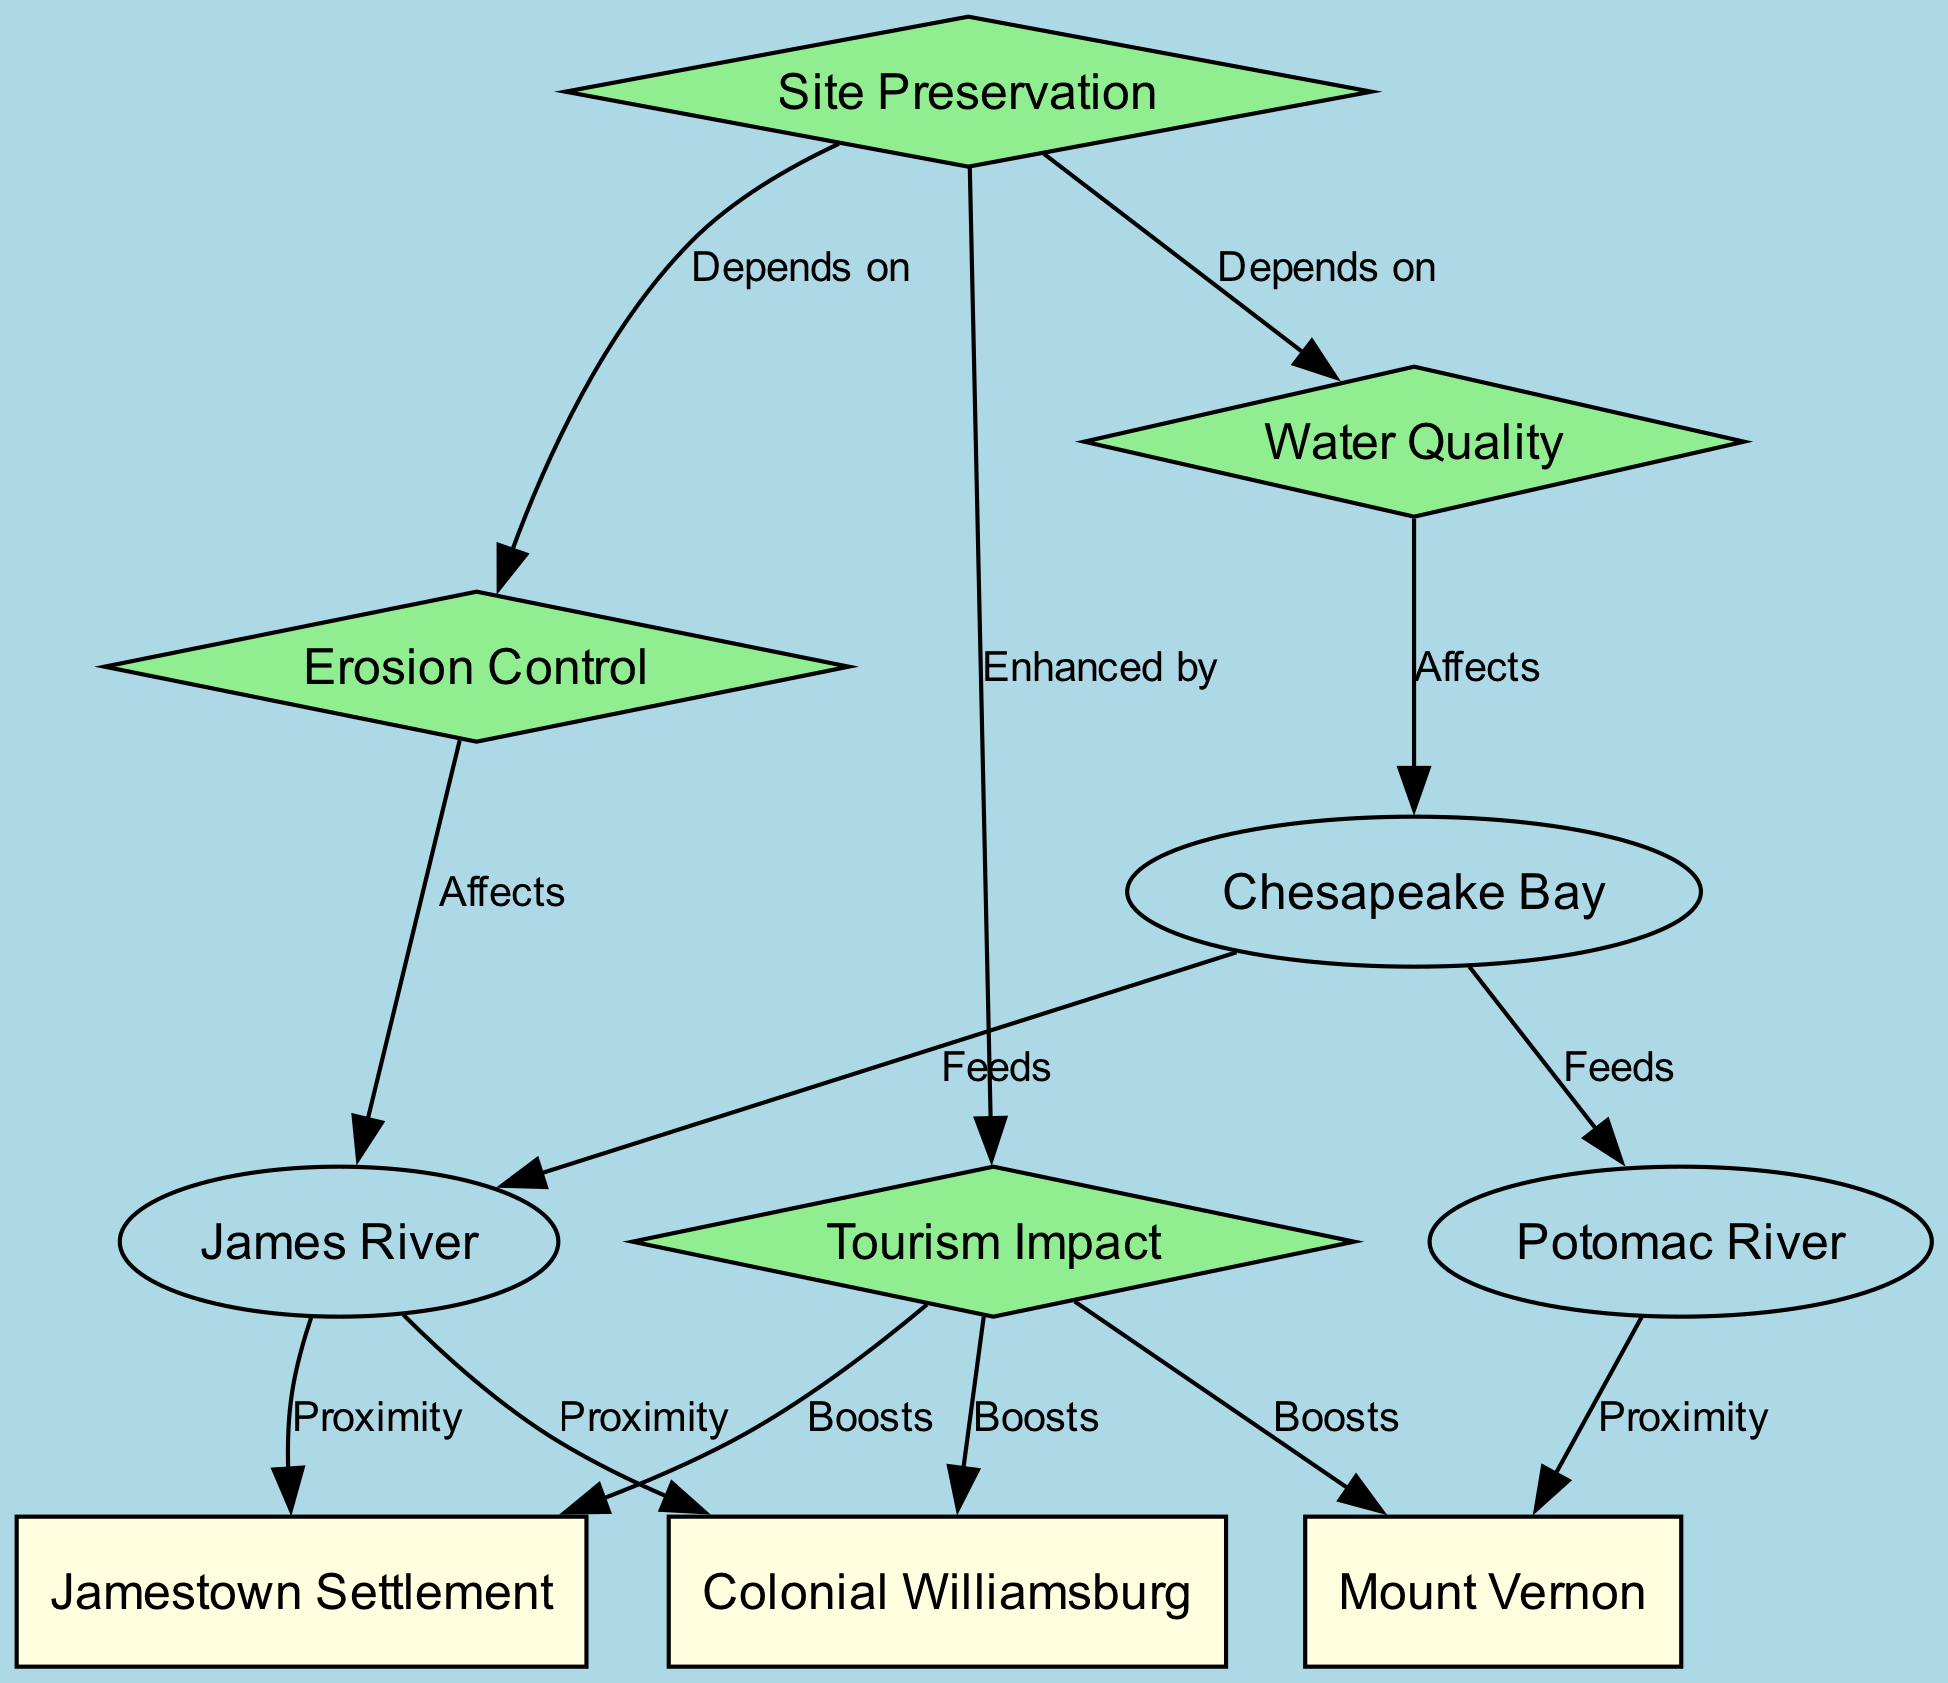What are the three main water bodies depicted in the diagram? The diagram clearly identifies three water bodies: Chesapeake Bay, James River, and Potomac River, all labeled as separate nodes.
Answer: Chesapeake Bay, James River, Potomac River Which historical site is closest to the James River? The diagram indicates that Colonial Williamsburg is in proximity to the James River, as evidenced by the edge labeled "Proximity" connecting these two nodes.
Answer: Colonial Williamsburg How many edges connect to the Chesapeake Bay node? Counting the edges leading from the Chesapeake Bay node, we see it connects to two water bodies (James River and Potomac River) and one water quality aspect, totaling three edges.
Answer: 3 Which factor affects water quality? Water quality is affected by several aspects in the diagram, but it is specifically indicated that erosion control influences the James River, which, in turn, affects the water quality in Chesapeake Bay.
Answer: Erosion Control How does site preservation enhance tourism impact? The diagram illustrates that site preservation depends on both water quality and erosion control, and it is also enhanced by tourism impact. This indicates a reciprocal relationship where maintaining sites contributes to tourism, while tourism interests can lead to preservation efforts.
Answer: Enhanced by What is the relationship between erosion control and the James River? The diagram specifically labels the connection as an "Affects" relationship, indicating that erosion control directly impacts the status or health of the James River.
Answer: Affects Which site is not directly connected to erosion control? Upon examining the nodes, Jamestown Settlement does not have a direct connection to the erosion control node, as it is primarily connected through the James River without a labeled relationship to erosion control.
Answer: Jamestown Settlement How many historical sites benefit from tourism impact according to the diagram? The diagram shows that three historical sites (Colonial Williamsburg, Mount Vernon, Jamestown Settlement) have a "Boosts" relationship with tourism impact, highlighting their benefit from increased visitor engagement.
Answer: 3 What does site preservation depend on? The diagram explicitly indicates that site preservation depends on two factors: water quality and erosion control, both connected to the site preservation node with "Depends on" edges.
Answer: Water Quality, Erosion Control 